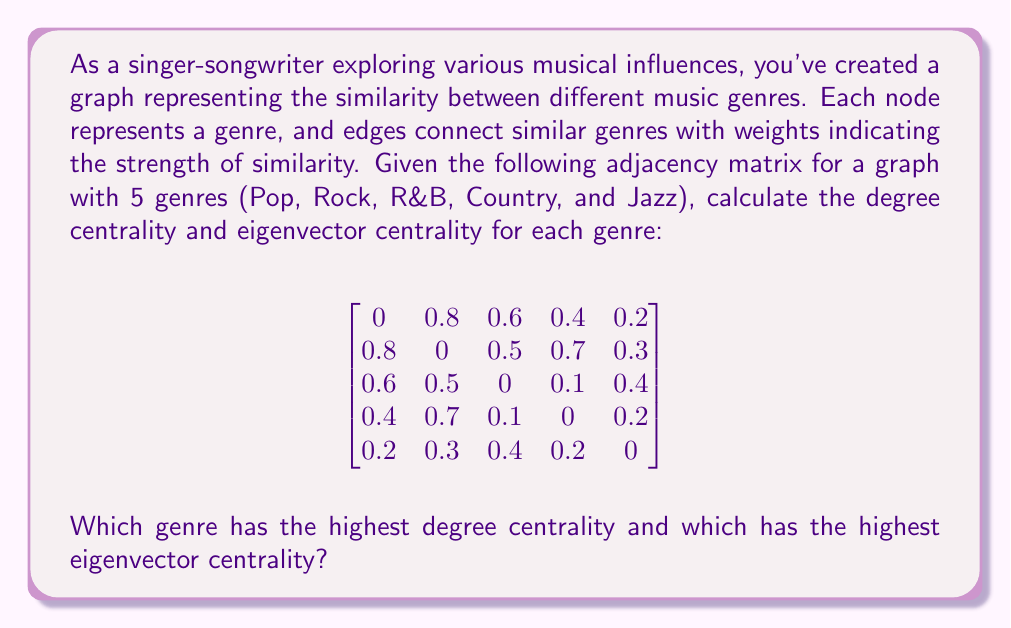Help me with this question. To solve this problem, we need to calculate two centrality measures for each genre: degree centrality and eigenvector centrality.

1. Degree Centrality:
Degree centrality is the sum of the weights of all edges connected to a node, normalized by the maximum possible degree (n-1, where n is the number of nodes).

For each genre:
Pop: $(0.8 + 0.6 + 0.4 + 0.2) / 4 = 0.5$
Rock: $(0.8 + 0.5 + 0.7 + 0.3) / 4 = 0.575$
R&B: $(0.6 + 0.5 + 0.1 + 0.4) / 4 = 0.4$
Country: $(0.4 + 0.7 + 0.1 + 0.2) / 4 = 0.35$
Jazz: $(0.2 + 0.3 + 0.4 + 0.2) / 4 = 0.275$

2. Eigenvector Centrality:
Eigenvector centrality is calculated by finding the principal eigenvector of the adjacency matrix. We can use the power iteration method to approximate this:

a) Start with an initial vector $\mathbf{x_0} = [1, 1, 1, 1, 1]^T$
b) Multiply the adjacency matrix by $\mathbf{x_0}$
c) Normalize the resulting vector
d) Repeat steps b and c until convergence

After several iterations, we get the approximate eigenvector:

$$\mathbf{x} \approx [0.3984, 0.4572, 0.3384, 0.3129, 0.2331]^T$$

This vector represents the eigenvector centrality scores for Pop, Rock, R&B, Country, and Jazz, respectively.
Answer: Rock has the highest degree centrality (0.575) and the highest eigenvector centrality (0.4572). 